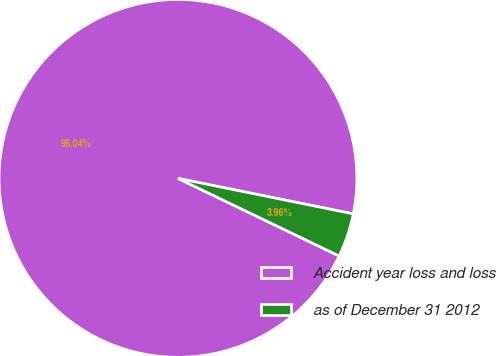<chart> <loc_0><loc_0><loc_500><loc_500><pie_chart><fcel>Accident year loss and loss<fcel>as of December 31 2012<nl><fcel>96.04%<fcel>3.96%<nl></chart> 